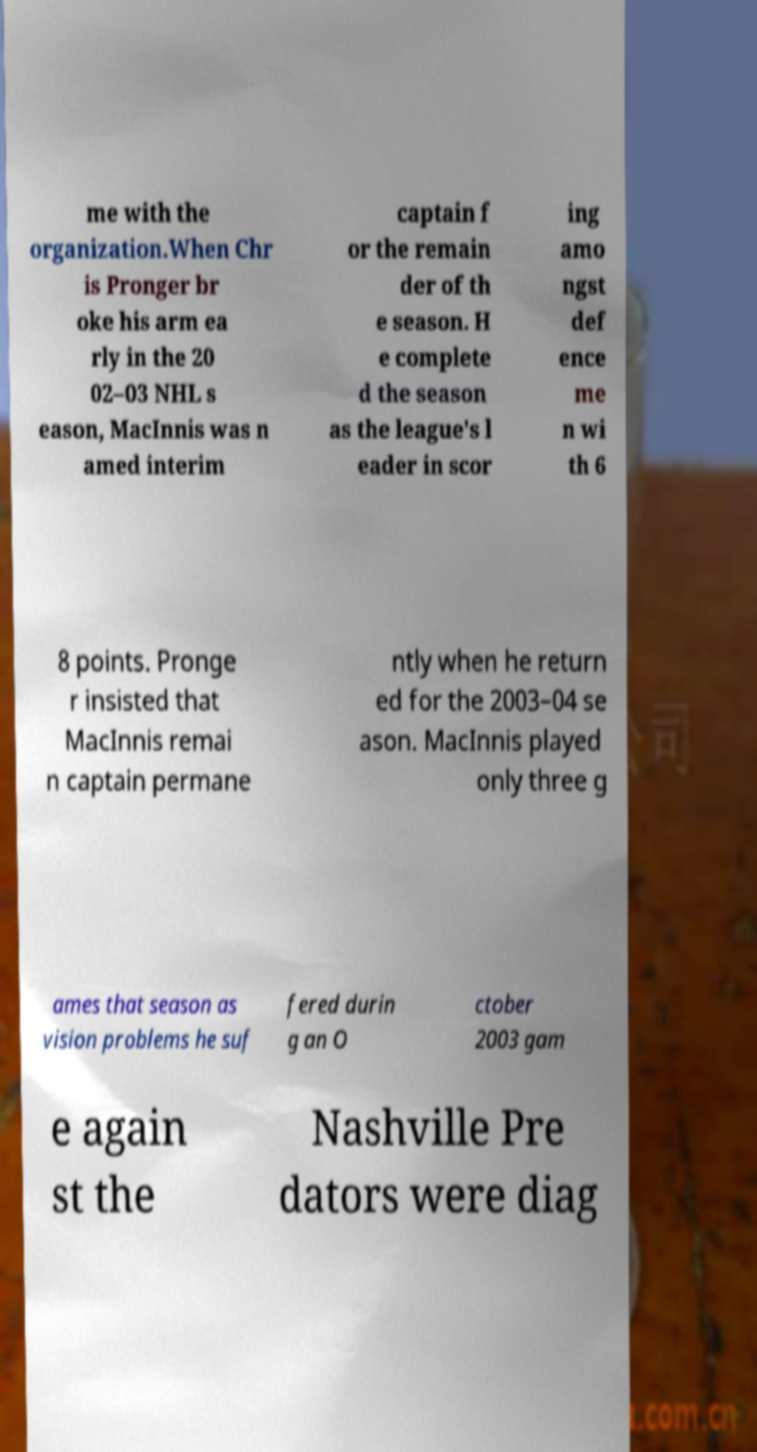What messages or text are displayed in this image? I need them in a readable, typed format. me with the organization.When Chr is Pronger br oke his arm ea rly in the 20 02–03 NHL s eason, MacInnis was n amed interim captain f or the remain der of th e season. H e complete d the season as the league's l eader in scor ing amo ngst def ence me n wi th 6 8 points. Pronge r insisted that MacInnis remai n captain permane ntly when he return ed for the 2003–04 se ason. MacInnis played only three g ames that season as vision problems he suf fered durin g an O ctober 2003 gam e again st the Nashville Pre dators were diag 